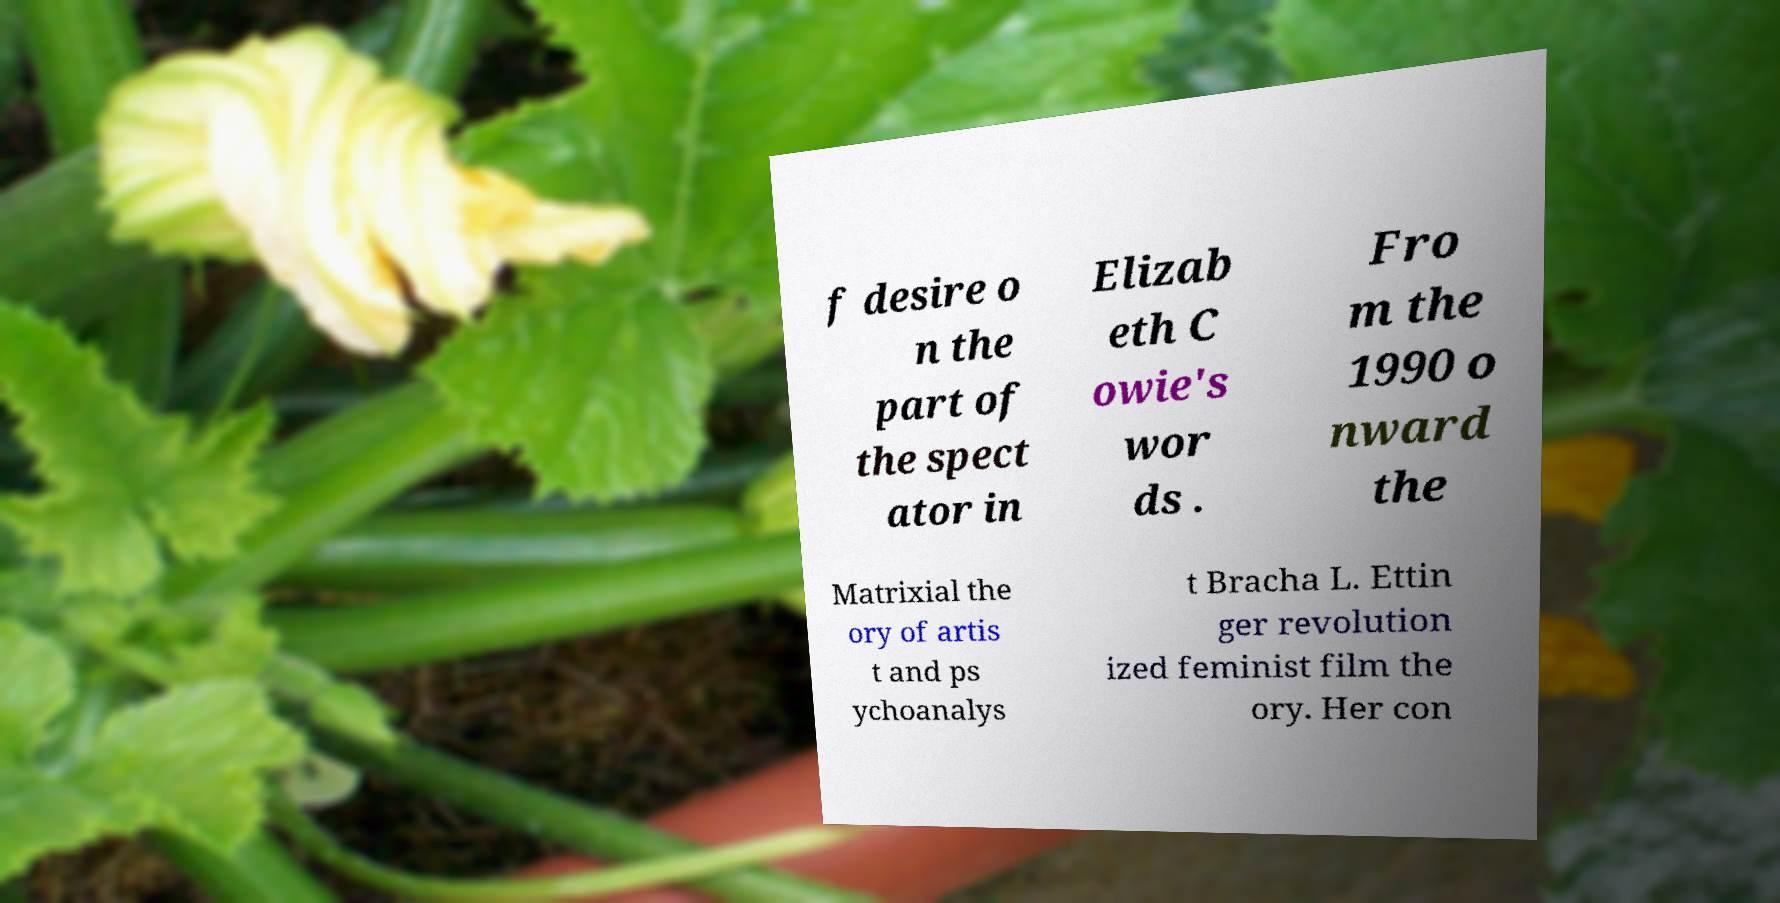Could you assist in decoding the text presented in this image and type it out clearly? f desire o n the part of the spect ator in Elizab eth C owie's wor ds . Fro m the 1990 o nward the Matrixial the ory of artis t and ps ychoanalys t Bracha L. Ettin ger revolution ized feminist film the ory. Her con 